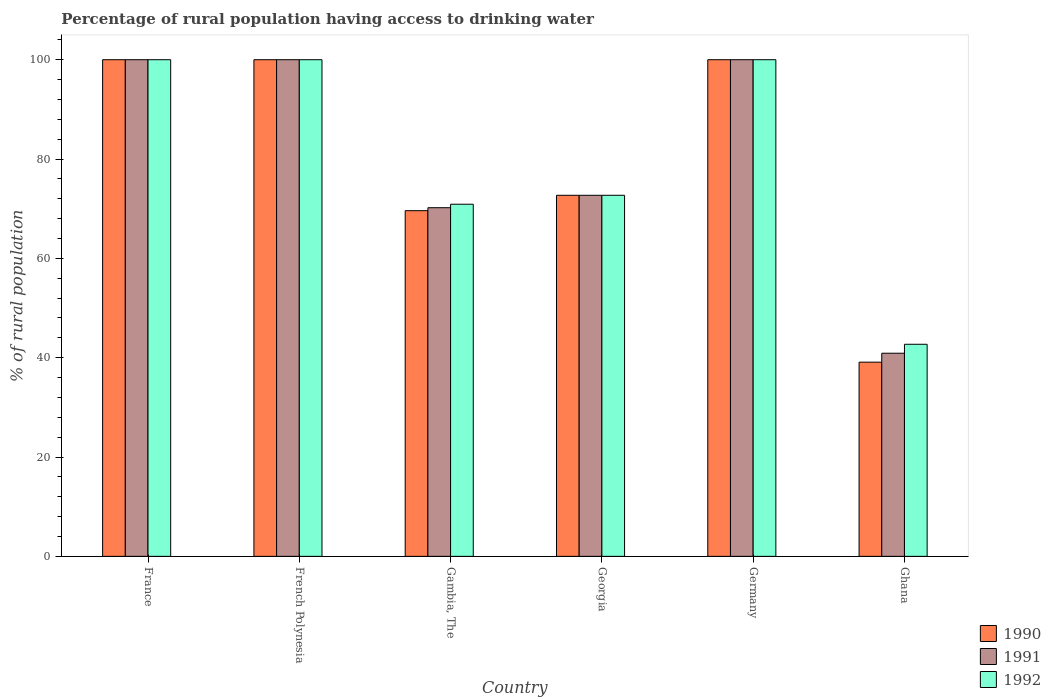How many different coloured bars are there?
Ensure brevity in your answer.  3. How many groups of bars are there?
Keep it short and to the point. 6. Are the number of bars on each tick of the X-axis equal?
Your answer should be very brief. Yes. In how many cases, is the number of bars for a given country not equal to the number of legend labels?
Offer a terse response. 0. What is the percentage of rural population having access to drinking water in 1991 in Ghana?
Your answer should be compact. 40.9. Across all countries, what is the maximum percentage of rural population having access to drinking water in 1992?
Provide a short and direct response. 100. Across all countries, what is the minimum percentage of rural population having access to drinking water in 1990?
Offer a very short reply. 39.1. In which country was the percentage of rural population having access to drinking water in 1991 maximum?
Provide a succinct answer. France. What is the total percentage of rural population having access to drinking water in 1992 in the graph?
Provide a short and direct response. 486.3. What is the difference between the percentage of rural population having access to drinking water in 1991 in French Polynesia and the percentage of rural population having access to drinking water in 1990 in Gambia, The?
Provide a short and direct response. 30.4. What is the average percentage of rural population having access to drinking water in 1990 per country?
Make the answer very short. 80.23. In how many countries, is the percentage of rural population having access to drinking water in 1991 greater than 24 %?
Provide a short and direct response. 6. Is the difference between the percentage of rural population having access to drinking water in 1992 in France and Germany greater than the difference between the percentage of rural population having access to drinking water in 1990 in France and Germany?
Your answer should be very brief. No. What is the difference between the highest and the lowest percentage of rural population having access to drinking water in 1992?
Offer a very short reply. 57.3. In how many countries, is the percentage of rural population having access to drinking water in 1992 greater than the average percentage of rural population having access to drinking water in 1992 taken over all countries?
Make the answer very short. 3. Is the sum of the percentage of rural population having access to drinking water in 1991 in Germany and Ghana greater than the maximum percentage of rural population having access to drinking water in 1992 across all countries?
Provide a short and direct response. Yes. What does the 1st bar from the left in Georgia represents?
Make the answer very short. 1990. What does the 1st bar from the right in French Polynesia represents?
Provide a succinct answer. 1992. Is it the case that in every country, the sum of the percentage of rural population having access to drinking water in 1990 and percentage of rural population having access to drinking water in 1991 is greater than the percentage of rural population having access to drinking water in 1992?
Your response must be concise. Yes. How many bars are there?
Your response must be concise. 18. Are all the bars in the graph horizontal?
Give a very brief answer. No. How many countries are there in the graph?
Your answer should be compact. 6. What is the difference between two consecutive major ticks on the Y-axis?
Give a very brief answer. 20. Are the values on the major ticks of Y-axis written in scientific E-notation?
Keep it short and to the point. No. Does the graph contain grids?
Offer a very short reply. No. Where does the legend appear in the graph?
Provide a short and direct response. Bottom right. How are the legend labels stacked?
Provide a short and direct response. Vertical. What is the title of the graph?
Keep it short and to the point. Percentage of rural population having access to drinking water. Does "1979" appear as one of the legend labels in the graph?
Your response must be concise. No. What is the label or title of the X-axis?
Make the answer very short. Country. What is the label or title of the Y-axis?
Ensure brevity in your answer.  % of rural population. What is the % of rural population of 1990 in France?
Keep it short and to the point. 100. What is the % of rural population of 1990 in French Polynesia?
Your answer should be very brief. 100. What is the % of rural population of 1990 in Gambia, The?
Provide a short and direct response. 69.6. What is the % of rural population of 1991 in Gambia, The?
Your response must be concise. 70.2. What is the % of rural population of 1992 in Gambia, The?
Your response must be concise. 70.9. What is the % of rural population of 1990 in Georgia?
Keep it short and to the point. 72.7. What is the % of rural population of 1991 in Georgia?
Provide a short and direct response. 72.7. What is the % of rural population of 1992 in Georgia?
Offer a very short reply. 72.7. What is the % of rural population of 1991 in Germany?
Your answer should be very brief. 100. What is the % of rural population in 1992 in Germany?
Make the answer very short. 100. What is the % of rural population of 1990 in Ghana?
Give a very brief answer. 39.1. What is the % of rural population of 1991 in Ghana?
Your answer should be compact. 40.9. What is the % of rural population of 1992 in Ghana?
Ensure brevity in your answer.  42.7. Across all countries, what is the maximum % of rural population of 1990?
Your answer should be compact. 100. Across all countries, what is the minimum % of rural population of 1990?
Provide a succinct answer. 39.1. Across all countries, what is the minimum % of rural population in 1991?
Your response must be concise. 40.9. Across all countries, what is the minimum % of rural population in 1992?
Your response must be concise. 42.7. What is the total % of rural population in 1990 in the graph?
Your answer should be compact. 481.4. What is the total % of rural population of 1991 in the graph?
Offer a terse response. 483.8. What is the total % of rural population of 1992 in the graph?
Your answer should be very brief. 486.3. What is the difference between the % of rural population of 1990 in France and that in French Polynesia?
Your response must be concise. 0. What is the difference between the % of rural population in 1991 in France and that in French Polynesia?
Keep it short and to the point. 0. What is the difference between the % of rural population of 1990 in France and that in Gambia, The?
Your answer should be very brief. 30.4. What is the difference between the % of rural population in 1991 in France and that in Gambia, The?
Ensure brevity in your answer.  29.8. What is the difference between the % of rural population in 1992 in France and that in Gambia, The?
Your answer should be compact. 29.1. What is the difference between the % of rural population of 1990 in France and that in Georgia?
Provide a short and direct response. 27.3. What is the difference between the % of rural population in 1991 in France and that in Georgia?
Ensure brevity in your answer.  27.3. What is the difference between the % of rural population in 1992 in France and that in Georgia?
Your response must be concise. 27.3. What is the difference between the % of rural population of 1990 in France and that in Germany?
Your answer should be very brief. 0. What is the difference between the % of rural population of 1991 in France and that in Germany?
Provide a short and direct response. 0. What is the difference between the % of rural population in 1990 in France and that in Ghana?
Your response must be concise. 60.9. What is the difference between the % of rural population of 1991 in France and that in Ghana?
Your response must be concise. 59.1. What is the difference between the % of rural population of 1992 in France and that in Ghana?
Ensure brevity in your answer.  57.3. What is the difference between the % of rural population of 1990 in French Polynesia and that in Gambia, The?
Provide a short and direct response. 30.4. What is the difference between the % of rural population of 1991 in French Polynesia and that in Gambia, The?
Your response must be concise. 29.8. What is the difference between the % of rural population in 1992 in French Polynesia and that in Gambia, The?
Give a very brief answer. 29.1. What is the difference between the % of rural population in 1990 in French Polynesia and that in Georgia?
Offer a very short reply. 27.3. What is the difference between the % of rural population in 1991 in French Polynesia and that in Georgia?
Offer a terse response. 27.3. What is the difference between the % of rural population of 1992 in French Polynesia and that in Georgia?
Give a very brief answer. 27.3. What is the difference between the % of rural population of 1990 in French Polynesia and that in Germany?
Your answer should be compact. 0. What is the difference between the % of rural population in 1990 in French Polynesia and that in Ghana?
Offer a very short reply. 60.9. What is the difference between the % of rural population in 1991 in French Polynesia and that in Ghana?
Your answer should be compact. 59.1. What is the difference between the % of rural population of 1992 in French Polynesia and that in Ghana?
Your answer should be compact. 57.3. What is the difference between the % of rural population of 1990 in Gambia, The and that in Georgia?
Offer a terse response. -3.1. What is the difference between the % of rural population of 1992 in Gambia, The and that in Georgia?
Offer a very short reply. -1.8. What is the difference between the % of rural population of 1990 in Gambia, The and that in Germany?
Give a very brief answer. -30.4. What is the difference between the % of rural population in 1991 in Gambia, The and that in Germany?
Offer a very short reply. -29.8. What is the difference between the % of rural population in 1992 in Gambia, The and that in Germany?
Your response must be concise. -29.1. What is the difference between the % of rural population in 1990 in Gambia, The and that in Ghana?
Your response must be concise. 30.5. What is the difference between the % of rural population in 1991 in Gambia, The and that in Ghana?
Keep it short and to the point. 29.3. What is the difference between the % of rural population of 1992 in Gambia, The and that in Ghana?
Provide a succinct answer. 28.2. What is the difference between the % of rural population of 1990 in Georgia and that in Germany?
Provide a succinct answer. -27.3. What is the difference between the % of rural population in 1991 in Georgia and that in Germany?
Offer a very short reply. -27.3. What is the difference between the % of rural population of 1992 in Georgia and that in Germany?
Offer a terse response. -27.3. What is the difference between the % of rural population in 1990 in Georgia and that in Ghana?
Offer a very short reply. 33.6. What is the difference between the % of rural population in 1991 in Georgia and that in Ghana?
Ensure brevity in your answer.  31.8. What is the difference between the % of rural population in 1992 in Georgia and that in Ghana?
Your answer should be very brief. 30. What is the difference between the % of rural population of 1990 in Germany and that in Ghana?
Make the answer very short. 60.9. What is the difference between the % of rural population in 1991 in Germany and that in Ghana?
Your response must be concise. 59.1. What is the difference between the % of rural population in 1992 in Germany and that in Ghana?
Make the answer very short. 57.3. What is the difference between the % of rural population of 1990 in France and the % of rural population of 1991 in French Polynesia?
Offer a terse response. 0. What is the difference between the % of rural population of 1990 in France and the % of rural population of 1992 in French Polynesia?
Give a very brief answer. 0. What is the difference between the % of rural population of 1991 in France and the % of rural population of 1992 in French Polynesia?
Provide a succinct answer. 0. What is the difference between the % of rural population in 1990 in France and the % of rural population in 1991 in Gambia, The?
Your response must be concise. 29.8. What is the difference between the % of rural population in 1990 in France and the % of rural population in 1992 in Gambia, The?
Your answer should be compact. 29.1. What is the difference between the % of rural population in 1991 in France and the % of rural population in 1992 in Gambia, The?
Give a very brief answer. 29.1. What is the difference between the % of rural population of 1990 in France and the % of rural population of 1991 in Georgia?
Your answer should be compact. 27.3. What is the difference between the % of rural population in 1990 in France and the % of rural population in 1992 in Georgia?
Keep it short and to the point. 27.3. What is the difference between the % of rural population of 1991 in France and the % of rural population of 1992 in Georgia?
Offer a very short reply. 27.3. What is the difference between the % of rural population of 1991 in France and the % of rural population of 1992 in Germany?
Provide a short and direct response. 0. What is the difference between the % of rural population in 1990 in France and the % of rural population in 1991 in Ghana?
Your answer should be very brief. 59.1. What is the difference between the % of rural population of 1990 in France and the % of rural population of 1992 in Ghana?
Make the answer very short. 57.3. What is the difference between the % of rural population in 1991 in France and the % of rural population in 1992 in Ghana?
Your response must be concise. 57.3. What is the difference between the % of rural population of 1990 in French Polynesia and the % of rural population of 1991 in Gambia, The?
Your answer should be compact. 29.8. What is the difference between the % of rural population in 1990 in French Polynesia and the % of rural population in 1992 in Gambia, The?
Give a very brief answer. 29.1. What is the difference between the % of rural population of 1991 in French Polynesia and the % of rural population of 1992 in Gambia, The?
Make the answer very short. 29.1. What is the difference between the % of rural population in 1990 in French Polynesia and the % of rural population in 1991 in Georgia?
Offer a very short reply. 27.3. What is the difference between the % of rural population of 1990 in French Polynesia and the % of rural population of 1992 in Georgia?
Give a very brief answer. 27.3. What is the difference between the % of rural population of 1991 in French Polynesia and the % of rural population of 1992 in Georgia?
Your response must be concise. 27.3. What is the difference between the % of rural population of 1990 in French Polynesia and the % of rural population of 1991 in Germany?
Offer a terse response. 0. What is the difference between the % of rural population of 1990 in French Polynesia and the % of rural population of 1992 in Germany?
Your answer should be compact. 0. What is the difference between the % of rural population of 1991 in French Polynesia and the % of rural population of 1992 in Germany?
Provide a short and direct response. 0. What is the difference between the % of rural population in 1990 in French Polynesia and the % of rural population in 1991 in Ghana?
Ensure brevity in your answer.  59.1. What is the difference between the % of rural population in 1990 in French Polynesia and the % of rural population in 1992 in Ghana?
Ensure brevity in your answer.  57.3. What is the difference between the % of rural population of 1991 in French Polynesia and the % of rural population of 1992 in Ghana?
Make the answer very short. 57.3. What is the difference between the % of rural population of 1990 in Gambia, The and the % of rural population of 1992 in Georgia?
Provide a succinct answer. -3.1. What is the difference between the % of rural population of 1991 in Gambia, The and the % of rural population of 1992 in Georgia?
Offer a terse response. -2.5. What is the difference between the % of rural population in 1990 in Gambia, The and the % of rural population in 1991 in Germany?
Your answer should be compact. -30.4. What is the difference between the % of rural population in 1990 in Gambia, The and the % of rural population in 1992 in Germany?
Offer a terse response. -30.4. What is the difference between the % of rural population in 1991 in Gambia, The and the % of rural population in 1992 in Germany?
Give a very brief answer. -29.8. What is the difference between the % of rural population of 1990 in Gambia, The and the % of rural population of 1991 in Ghana?
Give a very brief answer. 28.7. What is the difference between the % of rural population in 1990 in Gambia, The and the % of rural population in 1992 in Ghana?
Provide a short and direct response. 26.9. What is the difference between the % of rural population of 1991 in Gambia, The and the % of rural population of 1992 in Ghana?
Offer a very short reply. 27.5. What is the difference between the % of rural population in 1990 in Georgia and the % of rural population in 1991 in Germany?
Offer a terse response. -27.3. What is the difference between the % of rural population in 1990 in Georgia and the % of rural population in 1992 in Germany?
Make the answer very short. -27.3. What is the difference between the % of rural population in 1991 in Georgia and the % of rural population in 1992 in Germany?
Your answer should be compact. -27.3. What is the difference between the % of rural population of 1990 in Georgia and the % of rural population of 1991 in Ghana?
Give a very brief answer. 31.8. What is the difference between the % of rural population of 1990 in Germany and the % of rural population of 1991 in Ghana?
Your response must be concise. 59.1. What is the difference between the % of rural population in 1990 in Germany and the % of rural population in 1992 in Ghana?
Your answer should be very brief. 57.3. What is the difference between the % of rural population of 1991 in Germany and the % of rural population of 1992 in Ghana?
Ensure brevity in your answer.  57.3. What is the average % of rural population of 1990 per country?
Make the answer very short. 80.23. What is the average % of rural population of 1991 per country?
Provide a succinct answer. 80.63. What is the average % of rural population of 1992 per country?
Keep it short and to the point. 81.05. What is the difference between the % of rural population in 1990 and % of rural population in 1991 in French Polynesia?
Provide a short and direct response. 0. What is the difference between the % of rural population in 1990 and % of rural population in 1992 in French Polynesia?
Keep it short and to the point. 0. What is the difference between the % of rural population of 1990 and % of rural population of 1991 in Gambia, The?
Your answer should be compact. -0.6. What is the difference between the % of rural population of 1990 and % of rural population of 1992 in Gambia, The?
Your answer should be compact. -1.3. What is the difference between the % of rural population of 1991 and % of rural population of 1992 in Gambia, The?
Your answer should be compact. -0.7. What is the difference between the % of rural population of 1990 and % of rural population of 1991 in Georgia?
Give a very brief answer. 0. What is the difference between the % of rural population of 1990 and % of rural population of 1992 in Georgia?
Your answer should be compact. 0. What is the difference between the % of rural population in 1990 and % of rural population in 1992 in Germany?
Offer a terse response. 0. What is the difference between the % of rural population in 1990 and % of rural population in 1991 in Ghana?
Your answer should be very brief. -1.8. What is the difference between the % of rural population of 1990 and % of rural population of 1992 in Ghana?
Ensure brevity in your answer.  -3.6. What is the difference between the % of rural population in 1991 and % of rural population in 1992 in Ghana?
Your response must be concise. -1.8. What is the ratio of the % of rural population of 1992 in France to that in French Polynesia?
Give a very brief answer. 1. What is the ratio of the % of rural population in 1990 in France to that in Gambia, The?
Keep it short and to the point. 1.44. What is the ratio of the % of rural population of 1991 in France to that in Gambia, The?
Provide a short and direct response. 1.42. What is the ratio of the % of rural population of 1992 in France to that in Gambia, The?
Offer a terse response. 1.41. What is the ratio of the % of rural population of 1990 in France to that in Georgia?
Provide a succinct answer. 1.38. What is the ratio of the % of rural population of 1991 in France to that in Georgia?
Provide a short and direct response. 1.38. What is the ratio of the % of rural population of 1992 in France to that in Georgia?
Offer a terse response. 1.38. What is the ratio of the % of rural population in 1990 in France to that in Germany?
Ensure brevity in your answer.  1. What is the ratio of the % of rural population of 1990 in France to that in Ghana?
Provide a short and direct response. 2.56. What is the ratio of the % of rural population in 1991 in France to that in Ghana?
Your answer should be very brief. 2.44. What is the ratio of the % of rural population in 1992 in France to that in Ghana?
Give a very brief answer. 2.34. What is the ratio of the % of rural population of 1990 in French Polynesia to that in Gambia, The?
Offer a terse response. 1.44. What is the ratio of the % of rural population of 1991 in French Polynesia to that in Gambia, The?
Provide a short and direct response. 1.42. What is the ratio of the % of rural population of 1992 in French Polynesia to that in Gambia, The?
Make the answer very short. 1.41. What is the ratio of the % of rural population of 1990 in French Polynesia to that in Georgia?
Your answer should be compact. 1.38. What is the ratio of the % of rural population of 1991 in French Polynesia to that in Georgia?
Offer a terse response. 1.38. What is the ratio of the % of rural population of 1992 in French Polynesia to that in Georgia?
Offer a very short reply. 1.38. What is the ratio of the % of rural population of 1990 in French Polynesia to that in Germany?
Your answer should be compact. 1. What is the ratio of the % of rural population of 1991 in French Polynesia to that in Germany?
Ensure brevity in your answer.  1. What is the ratio of the % of rural population in 1990 in French Polynesia to that in Ghana?
Provide a short and direct response. 2.56. What is the ratio of the % of rural population in 1991 in French Polynesia to that in Ghana?
Your answer should be very brief. 2.44. What is the ratio of the % of rural population of 1992 in French Polynesia to that in Ghana?
Ensure brevity in your answer.  2.34. What is the ratio of the % of rural population in 1990 in Gambia, The to that in Georgia?
Your answer should be compact. 0.96. What is the ratio of the % of rural population of 1991 in Gambia, The to that in Georgia?
Your response must be concise. 0.97. What is the ratio of the % of rural population of 1992 in Gambia, The to that in Georgia?
Keep it short and to the point. 0.98. What is the ratio of the % of rural population in 1990 in Gambia, The to that in Germany?
Ensure brevity in your answer.  0.7. What is the ratio of the % of rural population of 1991 in Gambia, The to that in Germany?
Provide a succinct answer. 0.7. What is the ratio of the % of rural population of 1992 in Gambia, The to that in Germany?
Your answer should be compact. 0.71. What is the ratio of the % of rural population of 1990 in Gambia, The to that in Ghana?
Give a very brief answer. 1.78. What is the ratio of the % of rural population of 1991 in Gambia, The to that in Ghana?
Ensure brevity in your answer.  1.72. What is the ratio of the % of rural population in 1992 in Gambia, The to that in Ghana?
Offer a terse response. 1.66. What is the ratio of the % of rural population in 1990 in Georgia to that in Germany?
Offer a very short reply. 0.73. What is the ratio of the % of rural population in 1991 in Georgia to that in Germany?
Offer a very short reply. 0.73. What is the ratio of the % of rural population of 1992 in Georgia to that in Germany?
Offer a terse response. 0.73. What is the ratio of the % of rural population of 1990 in Georgia to that in Ghana?
Offer a very short reply. 1.86. What is the ratio of the % of rural population in 1991 in Georgia to that in Ghana?
Your response must be concise. 1.78. What is the ratio of the % of rural population in 1992 in Georgia to that in Ghana?
Make the answer very short. 1.7. What is the ratio of the % of rural population of 1990 in Germany to that in Ghana?
Make the answer very short. 2.56. What is the ratio of the % of rural population of 1991 in Germany to that in Ghana?
Offer a very short reply. 2.44. What is the ratio of the % of rural population of 1992 in Germany to that in Ghana?
Make the answer very short. 2.34. What is the difference between the highest and the second highest % of rural population of 1991?
Ensure brevity in your answer.  0. What is the difference between the highest and the lowest % of rural population of 1990?
Your response must be concise. 60.9. What is the difference between the highest and the lowest % of rural population in 1991?
Keep it short and to the point. 59.1. What is the difference between the highest and the lowest % of rural population of 1992?
Your response must be concise. 57.3. 